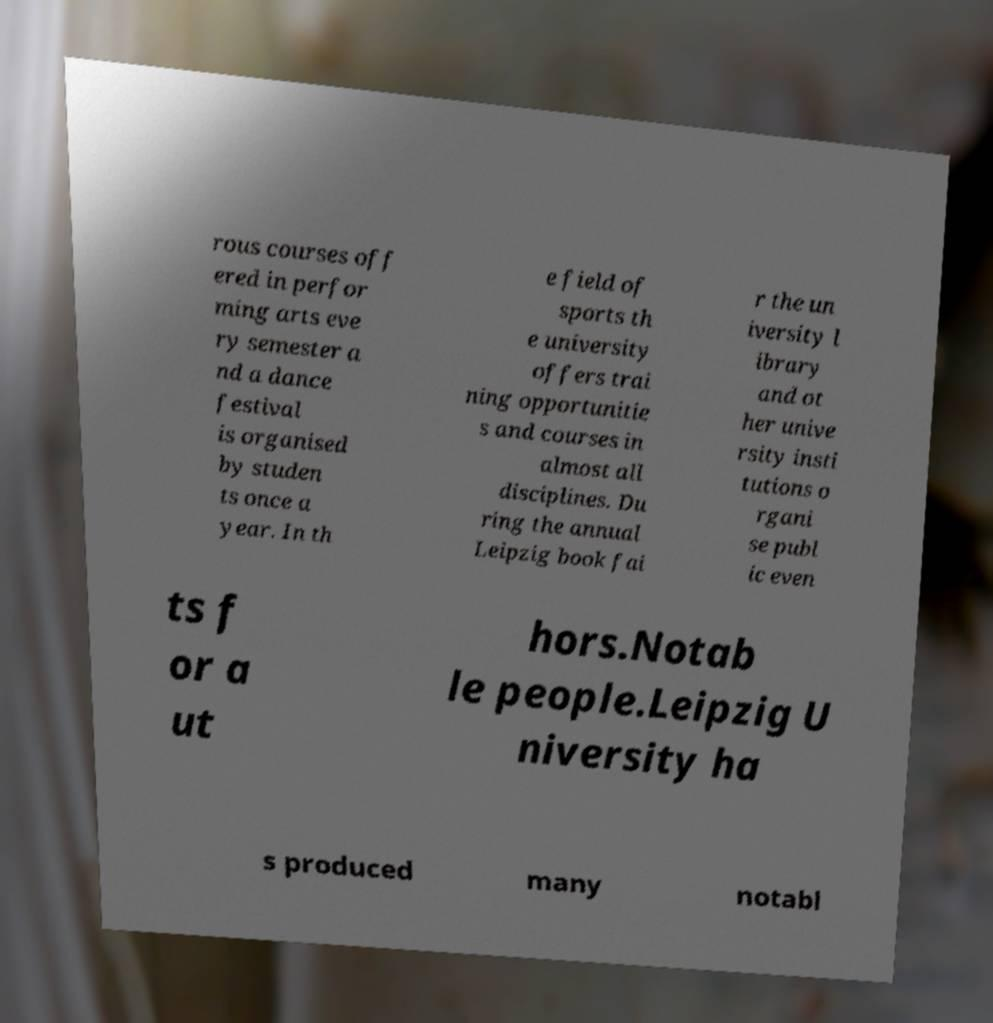Can you accurately transcribe the text from the provided image for me? rous courses off ered in perfor ming arts eve ry semester a nd a dance festival is organised by studen ts once a year. In th e field of sports th e university offers trai ning opportunitie s and courses in almost all disciplines. Du ring the annual Leipzig book fai r the un iversity l ibrary and ot her unive rsity insti tutions o rgani se publ ic even ts f or a ut hors.Notab le people.Leipzig U niversity ha s produced many notabl 